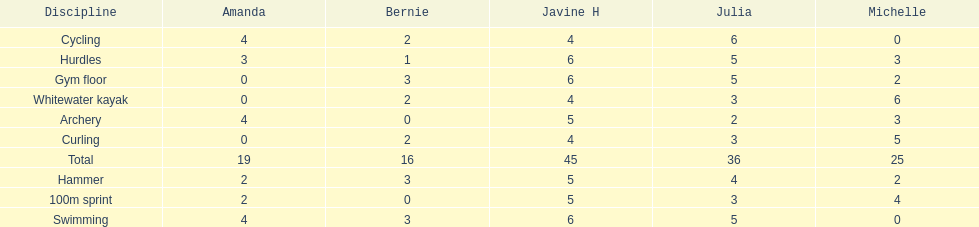What other girl besides amanda also had a 4 in cycling? Javine H. 